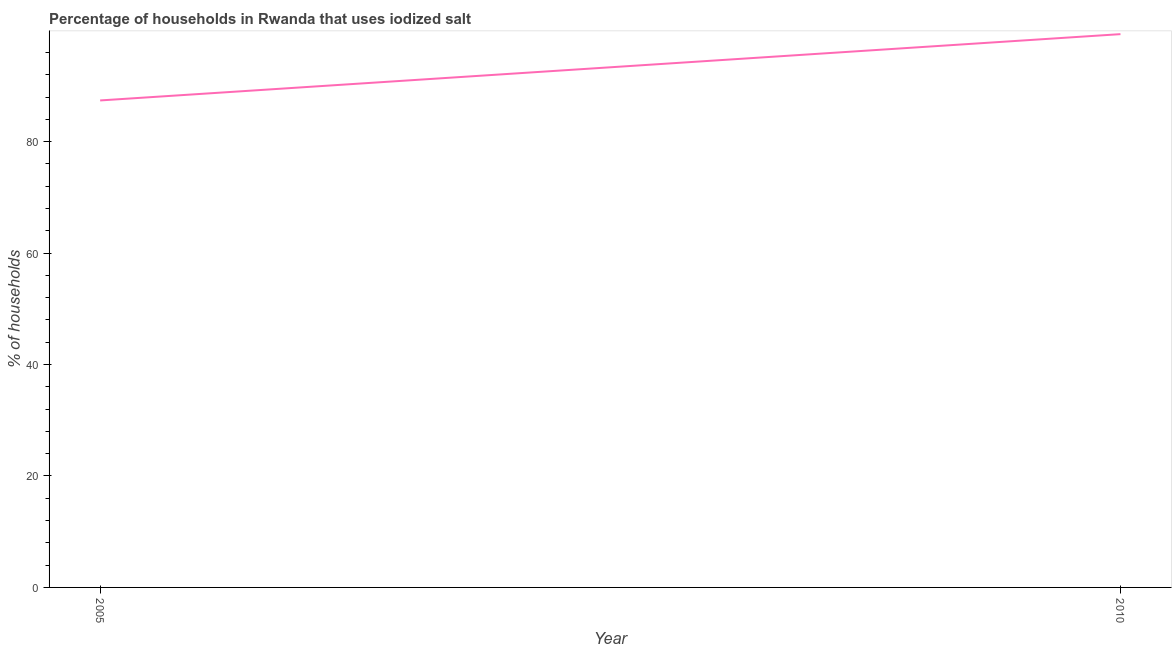What is the percentage of households where iodized salt is consumed in 2010?
Ensure brevity in your answer.  99.3. Across all years, what is the maximum percentage of households where iodized salt is consumed?
Your answer should be compact. 99.3. Across all years, what is the minimum percentage of households where iodized salt is consumed?
Offer a terse response. 87.4. In which year was the percentage of households where iodized salt is consumed minimum?
Provide a short and direct response. 2005. What is the sum of the percentage of households where iodized salt is consumed?
Your answer should be very brief. 186.7. What is the difference between the percentage of households where iodized salt is consumed in 2005 and 2010?
Make the answer very short. -11.9. What is the average percentage of households where iodized salt is consumed per year?
Your answer should be compact. 93.35. What is the median percentage of households where iodized salt is consumed?
Offer a very short reply. 93.35. What is the ratio of the percentage of households where iodized salt is consumed in 2005 to that in 2010?
Keep it short and to the point. 0.88. Is the percentage of households where iodized salt is consumed in 2005 less than that in 2010?
Make the answer very short. Yes. Does the percentage of households where iodized salt is consumed monotonically increase over the years?
Keep it short and to the point. Yes. How many years are there in the graph?
Offer a terse response. 2. Are the values on the major ticks of Y-axis written in scientific E-notation?
Your response must be concise. No. Does the graph contain grids?
Offer a terse response. No. What is the title of the graph?
Your answer should be very brief. Percentage of households in Rwanda that uses iodized salt. What is the label or title of the X-axis?
Give a very brief answer. Year. What is the label or title of the Y-axis?
Offer a very short reply. % of households. What is the % of households in 2005?
Your response must be concise. 87.4. What is the % of households in 2010?
Offer a terse response. 99.3. What is the difference between the % of households in 2005 and 2010?
Offer a terse response. -11.9. What is the ratio of the % of households in 2005 to that in 2010?
Ensure brevity in your answer.  0.88. 